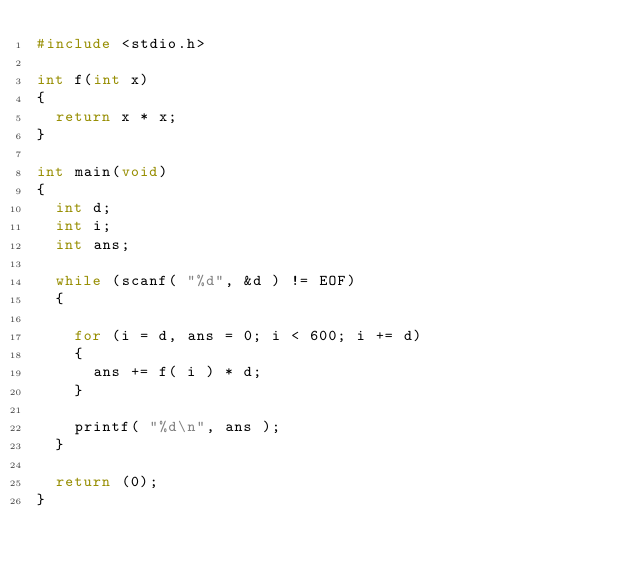<code> <loc_0><loc_0><loc_500><loc_500><_C_>#include <stdio.h>

int f(int x)
{
	return x * x;
}

int main(void)
{
	int d;
	int i;
	int ans;
	
	while (scanf( "%d", &d ) != EOF)
	{
		
		for (i = d, ans = 0; i < 600; i += d)
		{
			ans += f( i ) * d;
		}
		
		printf( "%d\n", ans );
	}
	
	return (0);
}</code> 